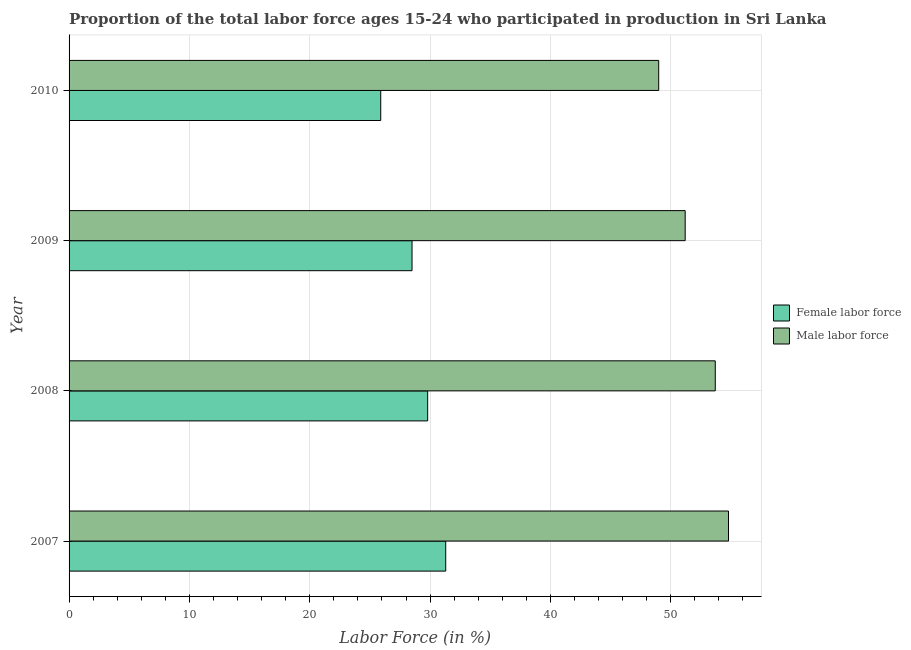How many different coloured bars are there?
Provide a succinct answer. 2. Are the number of bars per tick equal to the number of legend labels?
Ensure brevity in your answer.  Yes. Are the number of bars on each tick of the Y-axis equal?
Ensure brevity in your answer.  Yes. How many bars are there on the 1st tick from the top?
Offer a very short reply. 2. What is the label of the 4th group of bars from the top?
Make the answer very short. 2007. What is the percentage of female labor force in 2007?
Offer a terse response. 31.3. Across all years, what is the maximum percentage of male labour force?
Ensure brevity in your answer.  54.8. In which year was the percentage of male labour force maximum?
Your answer should be very brief. 2007. What is the total percentage of female labor force in the graph?
Your answer should be very brief. 115.5. What is the difference between the percentage of male labour force in 2008 and that in 2009?
Provide a succinct answer. 2.5. What is the difference between the percentage of male labour force in 2010 and the percentage of female labor force in 2007?
Ensure brevity in your answer.  17.7. What is the average percentage of female labor force per year?
Make the answer very short. 28.88. In the year 2010, what is the difference between the percentage of male labour force and percentage of female labor force?
Your answer should be very brief. 23.1. Is the percentage of female labor force in 2008 less than that in 2010?
Keep it short and to the point. No. What is the difference between the highest and the second highest percentage of female labor force?
Offer a terse response. 1.5. What is the difference between the highest and the lowest percentage of female labor force?
Your answer should be compact. 5.4. Is the sum of the percentage of female labor force in 2008 and 2010 greater than the maximum percentage of male labour force across all years?
Ensure brevity in your answer.  Yes. What does the 1st bar from the top in 2007 represents?
Your answer should be very brief. Male labor force. What does the 1st bar from the bottom in 2009 represents?
Give a very brief answer. Female labor force. How many bars are there?
Offer a terse response. 8. Are all the bars in the graph horizontal?
Your response must be concise. Yes. How many years are there in the graph?
Your response must be concise. 4. What is the difference between two consecutive major ticks on the X-axis?
Your answer should be compact. 10. Does the graph contain any zero values?
Offer a terse response. No. Does the graph contain grids?
Offer a terse response. Yes. Where does the legend appear in the graph?
Offer a terse response. Center right. What is the title of the graph?
Provide a short and direct response. Proportion of the total labor force ages 15-24 who participated in production in Sri Lanka. Does "Total Population" appear as one of the legend labels in the graph?
Your answer should be very brief. No. What is the label or title of the X-axis?
Your response must be concise. Labor Force (in %). What is the label or title of the Y-axis?
Your answer should be compact. Year. What is the Labor Force (in %) in Female labor force in 2007?
Give a very brief answer. 31.3. What is the Labor Force (in %) in Male labor force in 2007?
Your answer should be very brief. 54.8. What is the Labor Force (in %) of Female labor force in 2008?
Your response must be concise. 29.8. What is the Labor Force (in %) of Male labor force in 2008?
Offer a very short reply. 53.7. What is the Labor Force (in %) of Female labor force in 2009?
Make the answer very short. 28.5. What is the Labor Force (in %) of Male labor force in 2009?
Ensure brevity in your answer.  51.2. What is the Labor Force (in %) in Female labor force in 2010?
Ensure brevity in your answer.  25.9. What is the Labor Force (in %) of Male labor force in 2010?
Give a very brief answer. 49. Across all years, what is the maximum Labor Force (in %) of Female labor force?
Give a very brief answer. 31.3. Across all years, what is the maximum Labor Force (in %) in Male labor force?
Your answer should be very brief. 54.8. Across all years, what is the minimum Labor Force (in %) in Female labor force?
Make the answer very short. 25.9. What is the total Labor Force (in %) of Female labor force in the graph?
Provide a succinct answer. 115.5. What is the total Labor Force (in %) of Male labor force in the graph?
Your answer should be very brief. 208.7. What is the difference between the Labor Force (in %) in Female labor force in 2007 and that in 2008?
Your response must be concise. 1.5. What is the difference between the Labor Force (in %) in Male labor force in 2007 and that in 2008?
Your answer should be very brief. 1.1. What is the difference between the Labor Force (in %) in Male labor force in 2007 and that in 2009?
Give a very brief answer. 3.6. What is the difference between the Labor Force (in %) of Female labor force in 2008 and that in 2009?
Offer a terse response. 1.3. What is the difference between the Labor Force (in %) in Male labor force in 2008 and that in 2009?
Make the answer very short. 2.5. What is the difference between the Labor Force (in %) of Female labor force in 2009 and that in 2010?
Your answer should be compact. 2.6. What is the difference between the Labor Force (in %) of Female labor force in 2007 and the Labor Force (in %) of Male labor force in 2008?
Give a very brief answer. -22.4. What is the difference between the Labor Force (in %) in Female labor force in 2007 and the Labor Force (in %) in Male labor force in 2009?
Keep it short and to the point. -19.9. What is the difference between the Labor Force (in %) in Female labor force in 2007 and the Labor Force (in %) in Male labor force in 2010?
Your answer should be very brief. -17.7. What is the difference between the Labor Force (in %) of Female labor force in 2008 and the Labor Force (in %) of Male labor force in 2009?
Your answer should be very brief. -21.4. What is the difference between the Labor Force (in %) of Female labor force in 2008 and the Labor Force (in %) of Male labor force in 2010?
Offer a very short reply. -19.2. What is the difference between the Labor Force (in %) in Female labor force in 2009 and the Labor Force (in %) in Male labor force in 2010?
Provide a succinct answer. -20.5. What is the average Labor Force (in %) in Female labor force per year?
Provide a succinct answer. 28.88. What is the average Labor Force (in %) in Male labor force per year?
Your answer should be very brief. 52.17. In the year 2007, what is the difference between the Labor Force (in %) of Female labor force and Labor Force (in %) of Male labor force?
Keep it short and to the point. -23.5. In the year 2008, what is the difference between the Labor Force (in %) in Female labor force and Labor Force (in %) in Male labor force?
Provide a succinct answer. -23.9. In the year 2009, what is the difference between the Labor Force (in %) of Female labor force and Labor Force (in %) of Male labor force?
Provide a short and direct response. -22.7. In the year 2010, what is the difference between the Labor Force (in %) in Female labor force and Labor Force (in %) in Male labor force?
Your answer should be very brief. -23.1. What is the ratio of the Labor Force (in %) of Female labor force in 2007 to that in 2008?
Your response must be concise. 1.05. What is the ratio of the Labor Force (in %) in Male labor force in 2007 to that in 2008?
Keep it short and to the point. 1.02. What is the ratio of the Labor Force (in %) in Female labor force in 2007 to that in 2009?
Make the answer very short. 1.1. What is the ratio of the Labor Force (in %) in Male labor force in 2007 to that in 2009?
Offer a very short reply. 1.07. What is the ratio of the Labor Force (in %) of Female labor force in 2007 to that in 2010?
Offer a terse response. 1.21. What is the ratio of the Labor Force (in %) of Male labor force in 2007 to that in 2010?
Make the answer very short. 1.12. What is the ratio of the Labor Force (in %) of Female labor force in 2008 to that in 2009?
Your answer should be compact. 1.05. What is the ratio of the Labor Force (in %) in Male labor force in 2008 to that in 2009?
Your response must be concise. 1.05. What is the ratio of the Labor Force (in %) of Female labor force in 2008 to that in 2010?
Provide a short and direct response. 1.15. What is the ratio of the Labor Force (in %) of Male labor force in 2008 to that in 2010?
Provide a short and direct response. 1.1. What is the ratio of the Labor Force (in %) in Female labor force in 2009 to that in 2010?
Keep it short and to the point. 1.1. What is the ratio of the Labor Force (in %) of Male labor force in 2009 to that in 2010?
Give a very brief answer. 1.04. What is the difference between the highest and the second highest Labor Force (in %) of Female labor force?
Provide a succinct answer. 1.5. 